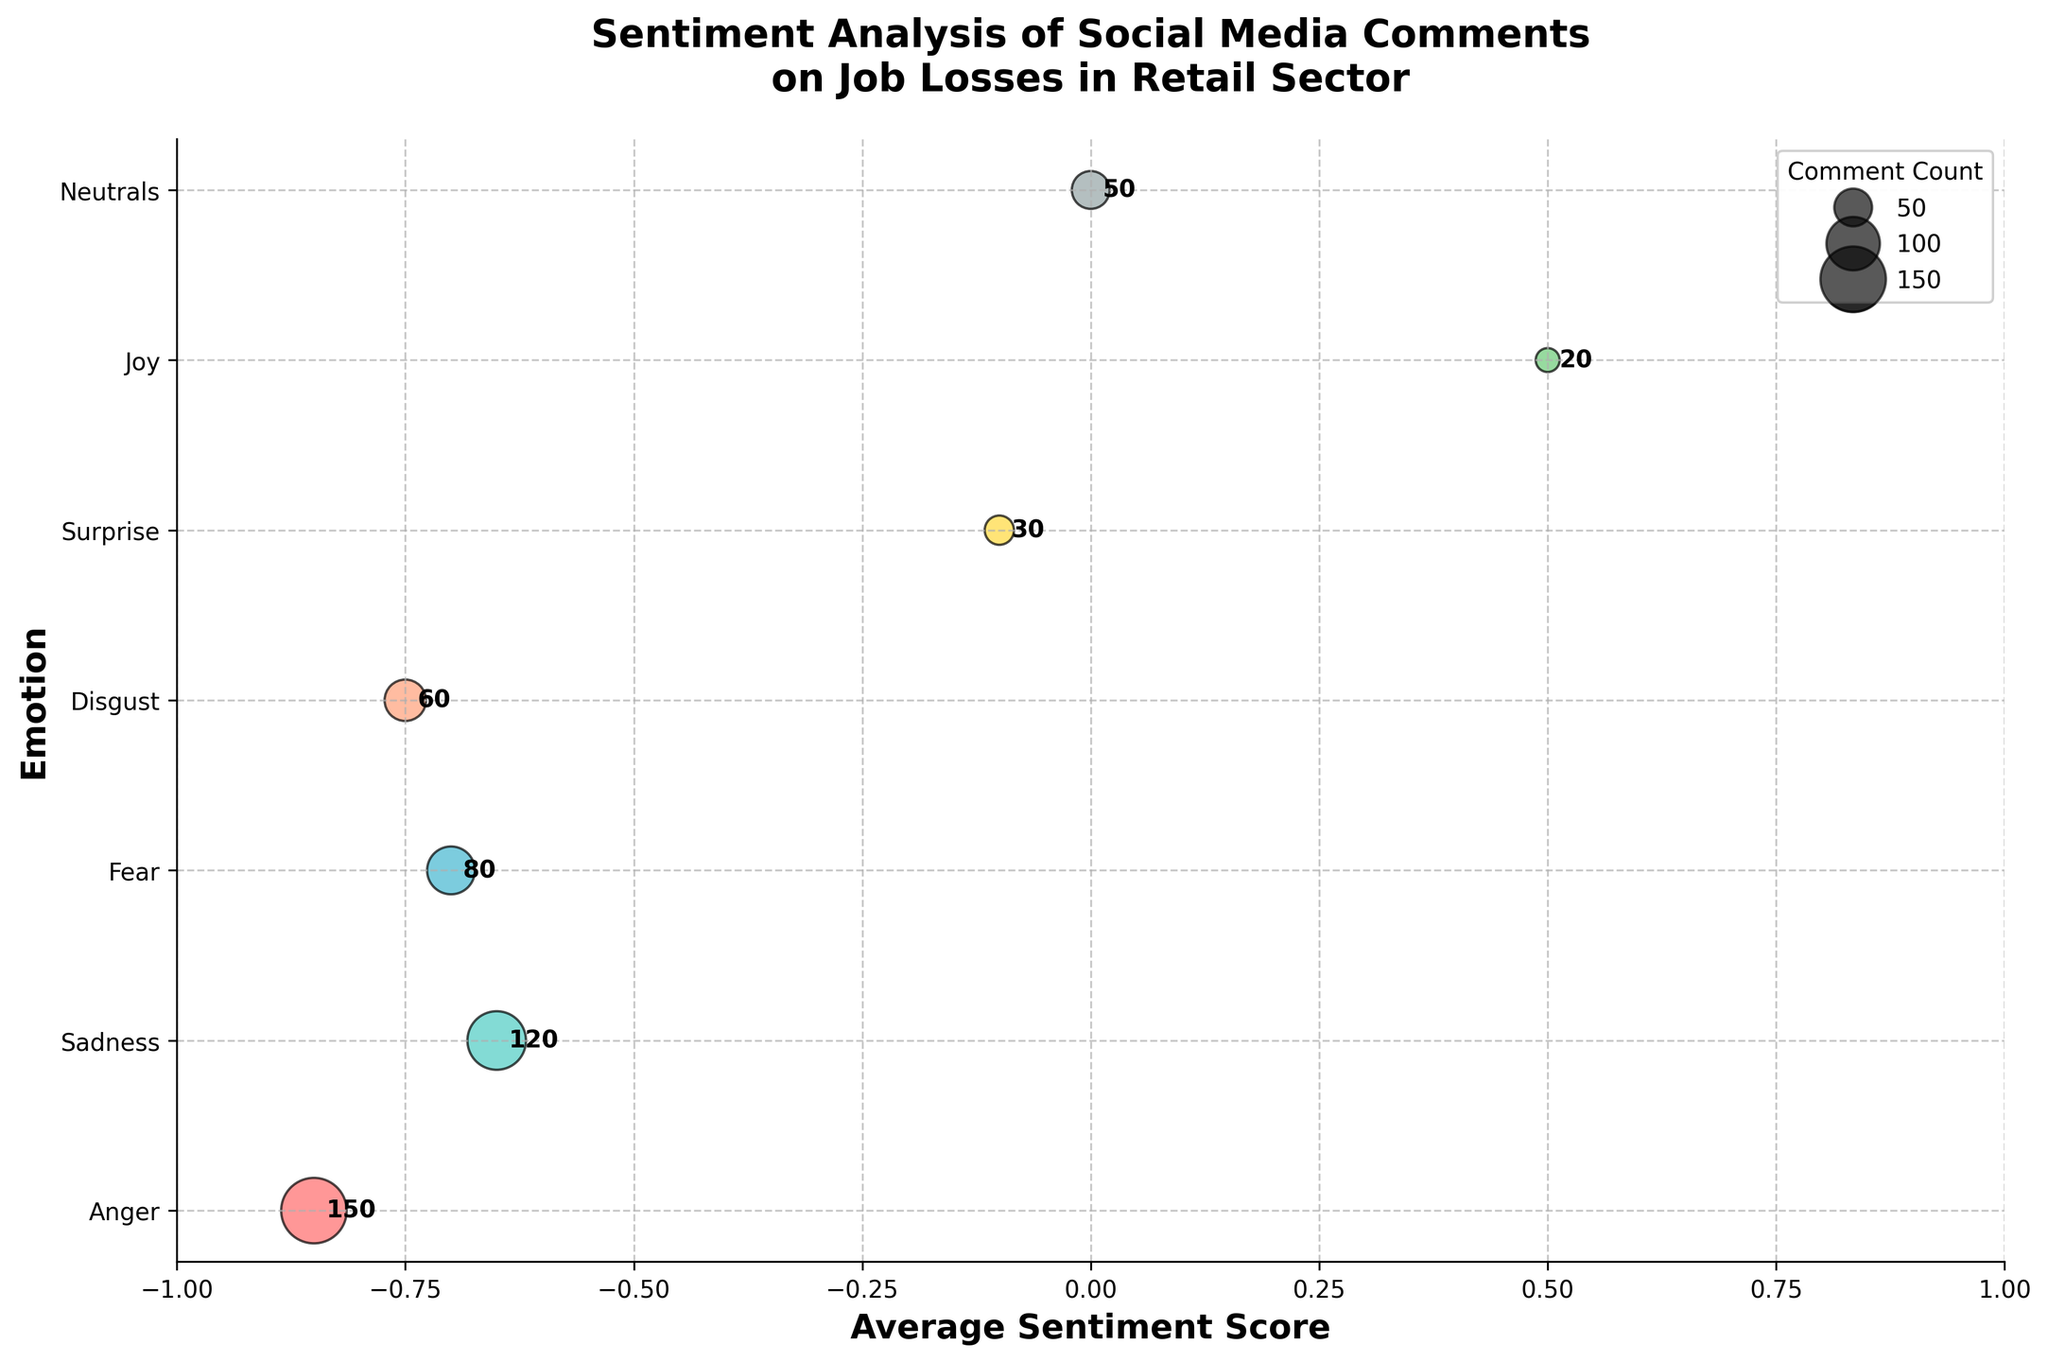What is the average sentiment score for "Anger"? The bubble representing "Anger" is plotted at an average sentiment score of -0.85 on the x-axis.
Answer: -0.85 Which emotion has the highest comment count? The largest bubble is for "Anger" with a comment count of 150, as annotated next to the bubble.
Answer: Anger What is the average sentiment score for "Joy"? The bubble for "Joy" is on the x-axis at an average sentiment score of 0.5.
Answer: 0.5 Which emotion has the lowest average sentiment score? "Anger" has the lowest average sentiment score, shown at -0.85 on the x-axis.
Answer: Anger How many emotions have a positive average sentiment score? Only "Joy" has a positive average sentiment score, as shown at 0.5 on the x-axis.
Answer: 1 Compare the comment counts for "Sadness" and "Fear". Which is higher? "Sadness" has a comment count of 120, while "Fear" has a comment count of 80 as annotated next to their bubbles.
Answer: Sadness What is the total comment count for emotions with negative average sentiment scores? Add the comment counts for "Anger" (150), "Sadness" (120), "Fear" (80), and "Disgust" (60): 150 + 120 + 80 + 60 = 410.
Answer: 410 Which emotion has the sentiment score closest to 0? "Surprise" is closest to 0 with an average sentiment score of -0.1.
Answer: Surprise How does the comment count for "Neutrals" compare to "Disgust"? "Neutrals" has a comment count of 50 and "Disgust" has a comment count of 60. So, "Disgust" has a slightly higher count.
Answer: Disgust What is the title of the chart? The title at the top of the chart is "Sentiment Analysis of Social Media Comments on Job Losses in Retail Sector".
Answer: Sentiment Analysis of Social Media Comments on Job Losses in Retail Sector 